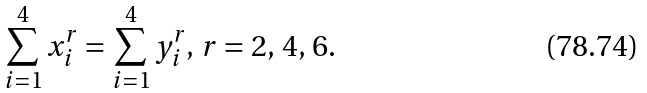<formula> <loc_0><loc_0><loc_500><loc_500>\sum _ { i = 1 } ^ { 4 } x _ { i } ^ { r } = \sum _ { i = 1 } ^ { 4 } y _ { i } ^ { r } , \, r = 2 , \, 4 , \, 6 .</formula> 